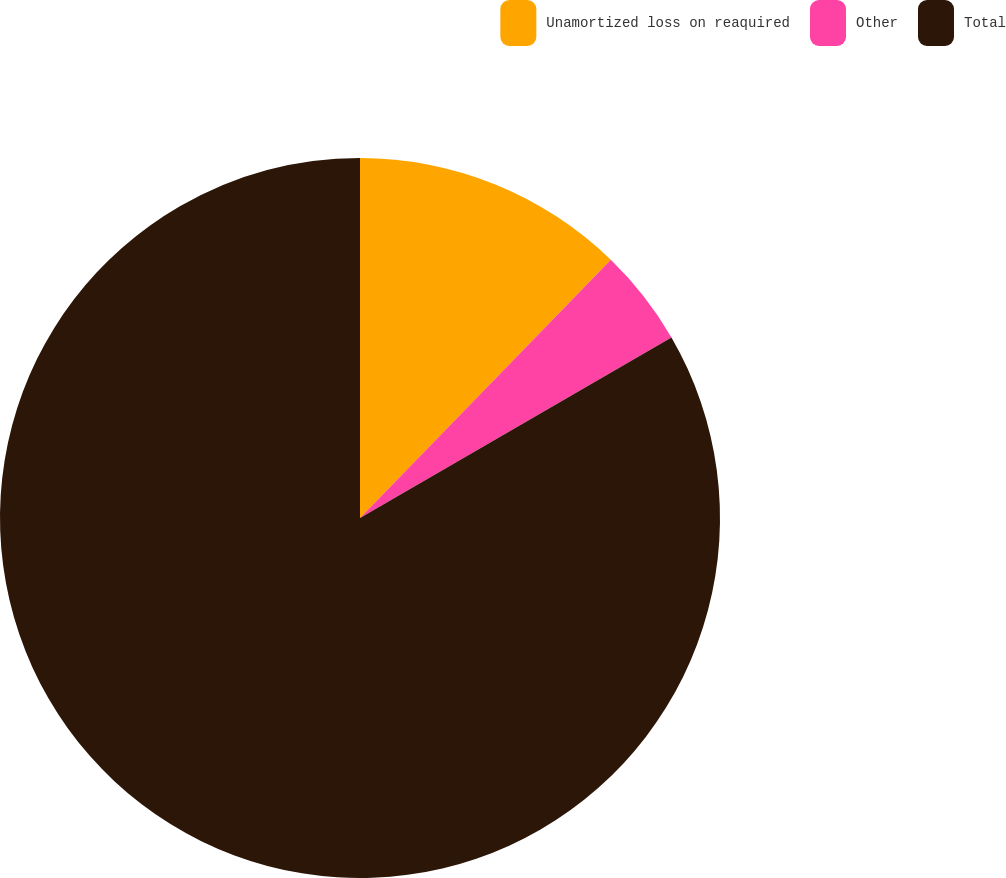Convert chart. <chart><loc_0><loc_0><loc_500><loc_500><pie_chart><fcel>Unamortized loss on reaquired<fcel>Other<fcel>Total<nl><fcel>12.27%<fcel>4.37%<fcel>83.37%<nl></chart> 